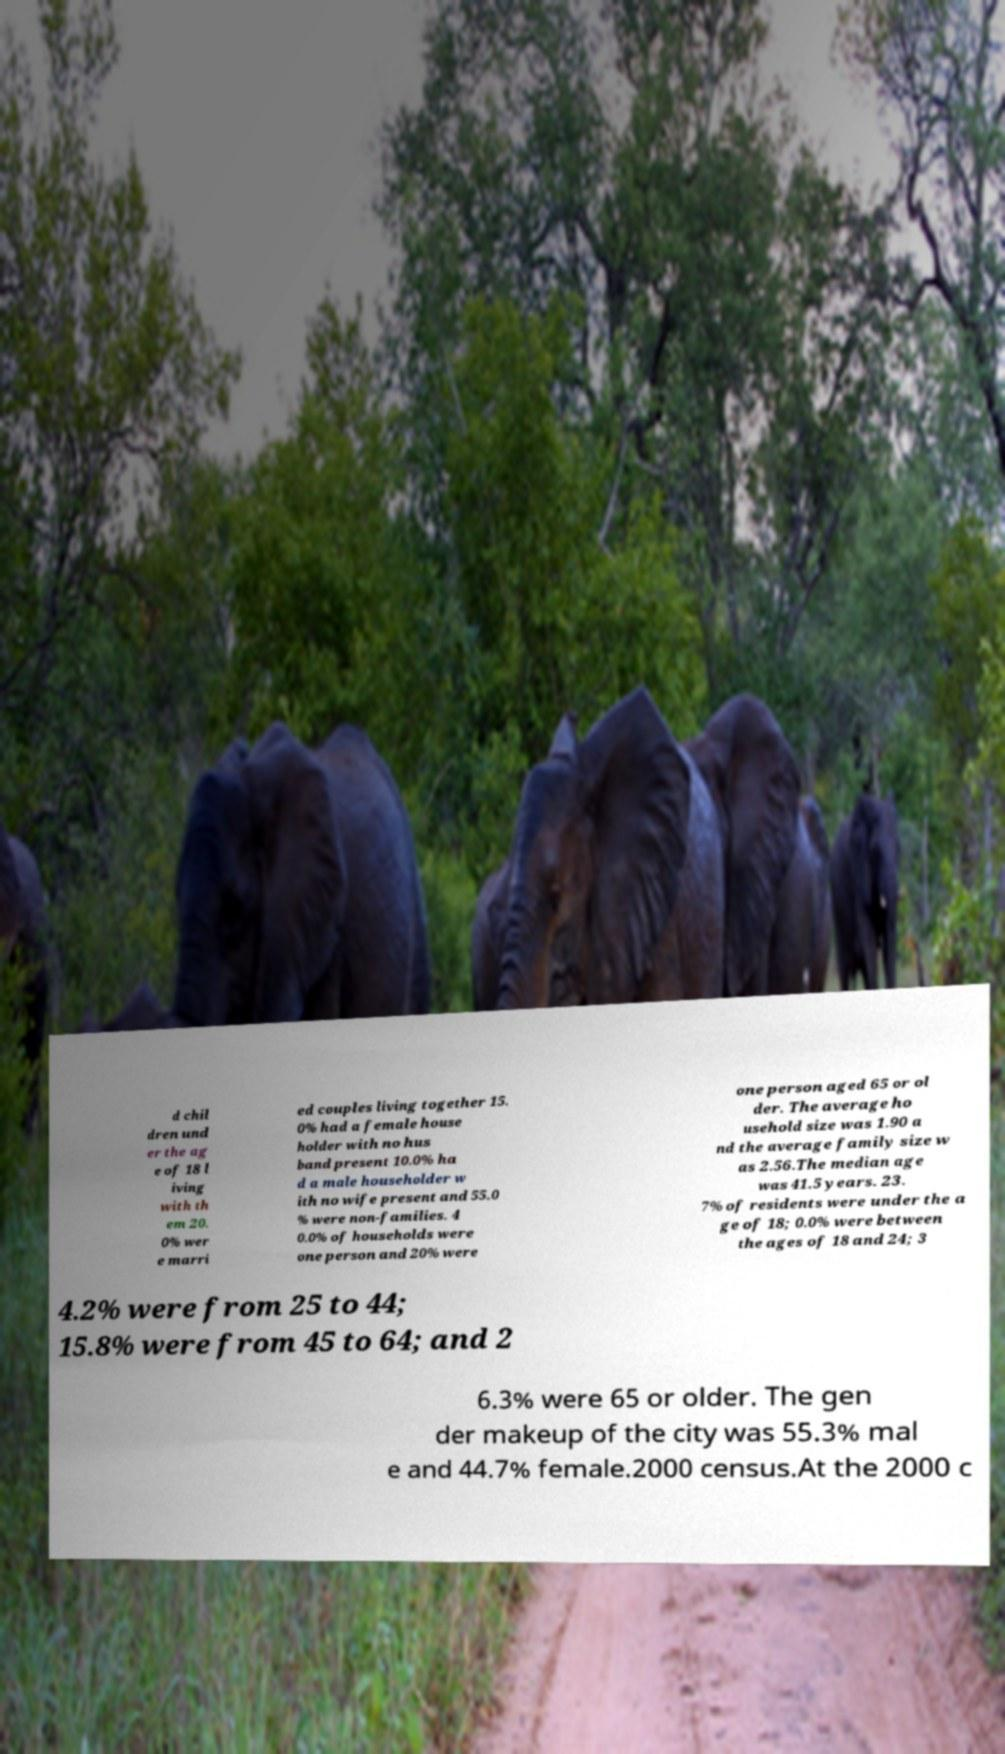There's text embedded in this image that I need extracted. Can you transcribe it verbatim? d chil dren und er the ag e of 18 l iving with th em 20. 0% wer e marri ed couples living together 15. 0% had a female house holder with no hus band present 10.0% ha d a male householder w ith no wife present and 55.0 % were non-families. 4 0.0% of households were one person and 20% were one person aged 65 or ol der. The average ho usehold size was 1.90 a nd the average family size w as 2.56.The median age was 41.5 years. 23. 7% of residents were under the a ge of 18; 0.0% were between the ages of 18 and 24; 3 4.2% were from 25 to 44; 15.8% were from 45 to 64; and 2 6.3% were 65 or older. The gen der makeup of the city was 55.3% mal e and 44.7% female.2000 census.At the 2000 c 